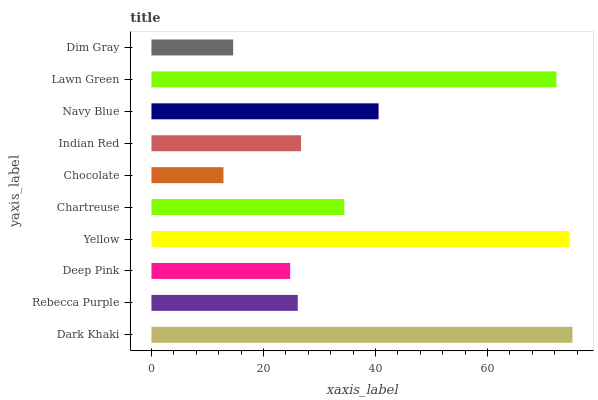Is Chocolate the minimum?
Answer yes or no. Yes. Is Dark Khaki the maximum?
Answer yes or no. Yes. Is Rebecca Purple the minimum?
Answer yes or no. No. Is Rebecca Purple the maximum?
Answer yes or no. No. Is Dark Khaki greater than Rebecca Purple?
Answer yes or no. Yes. Is Rebecca Purple less than Dark Khaki?
Answer yes or no. Yes. Is Rebecca Purple greater than Dark Khaki?
Answer yes or no. No. Is Dark Khaki less than Rebecca Purple?
Answer yes or no. No. Is Chartreuse the high median?
Answer yes or no. Yes. Is Indian Red the low median?
Answer yes or no. Yes. Is Chocolate the high median?
Answer yes or no. No. Is Rebecca Purple the low median?
Answer yes or no. No. 